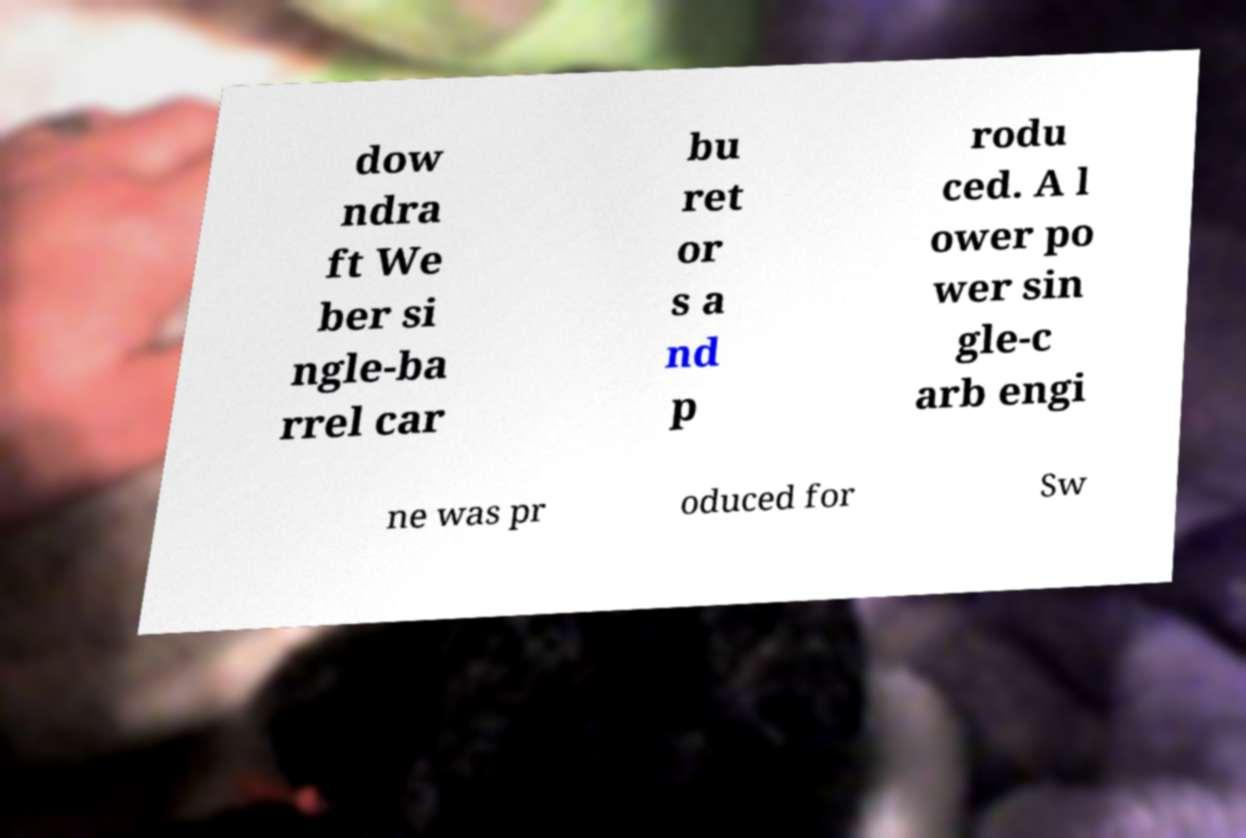Can you accurately transcribe the text from the provided image for me? dow ndra ft We ber si ngle-ba rrel car bu ret or s a nd p rodu ced. A l ower po wer sin gle-c arb engi ne was pr oduced for Sw 